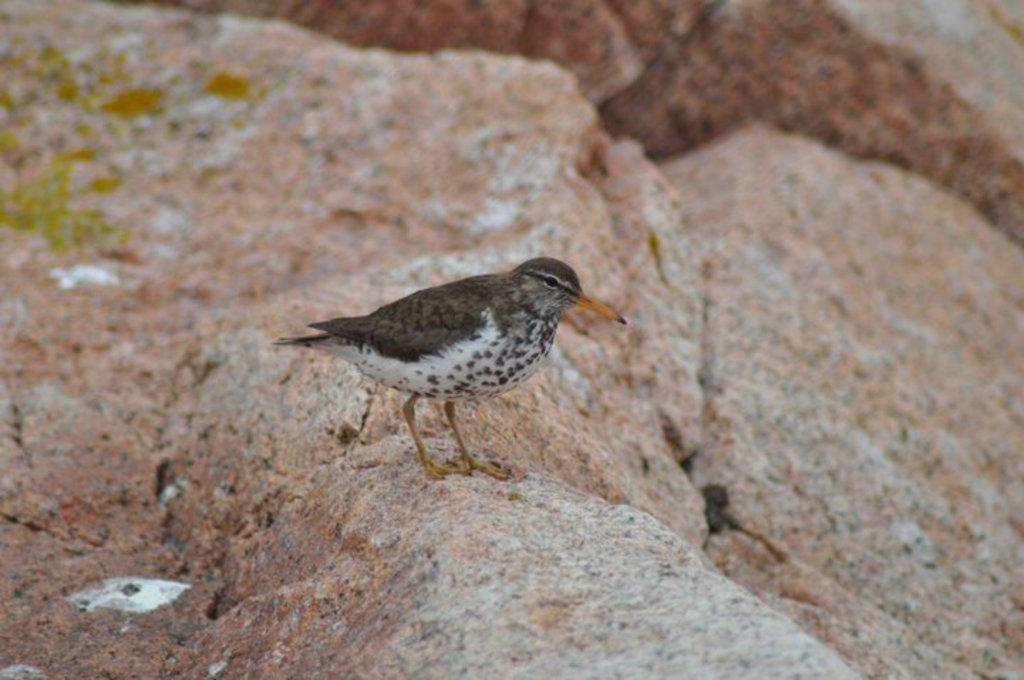What type of animal is present in the image? There is a bird in the image. What is the bird standing on? The bird is standing on a rock. What can be seen in the background of the image? There are rocks visible in the background of the image. What type of receipt can be seen in the bird's beak in the image? There is no receipt present in the image; it features a bird standing on a rock. What kind of flower is growing near the bird in the image? There is no flower present in the image; it only features a bird standing on a rock and rocks in the background. 